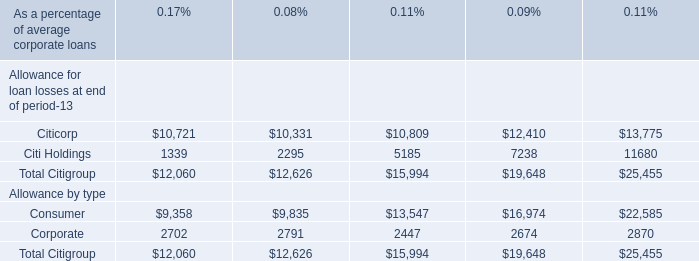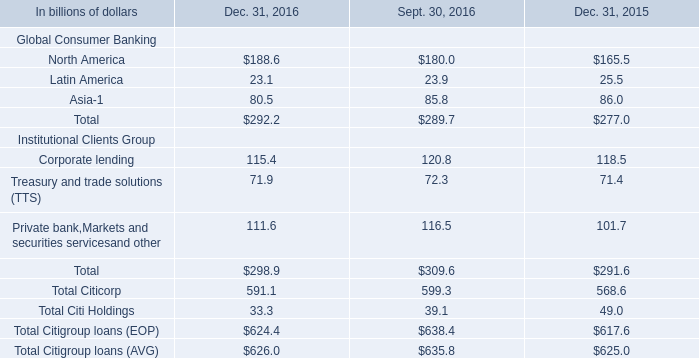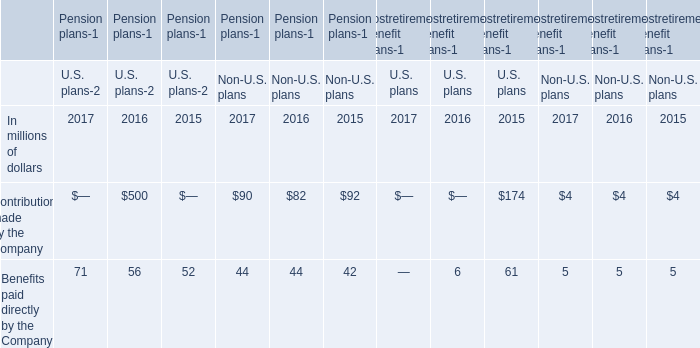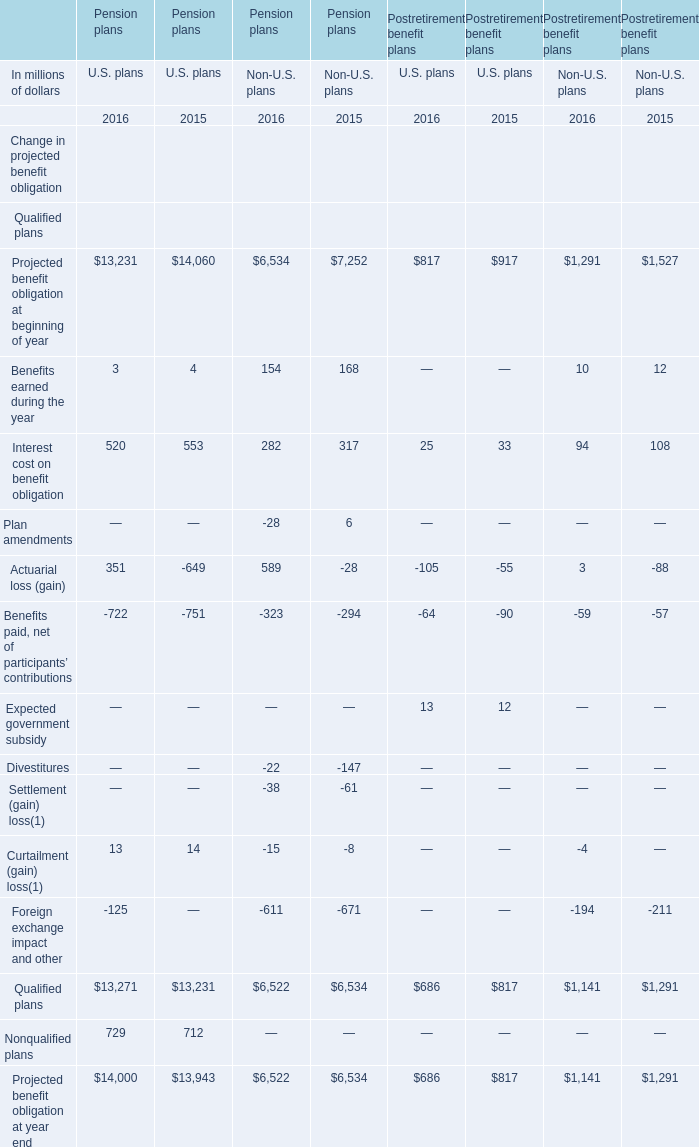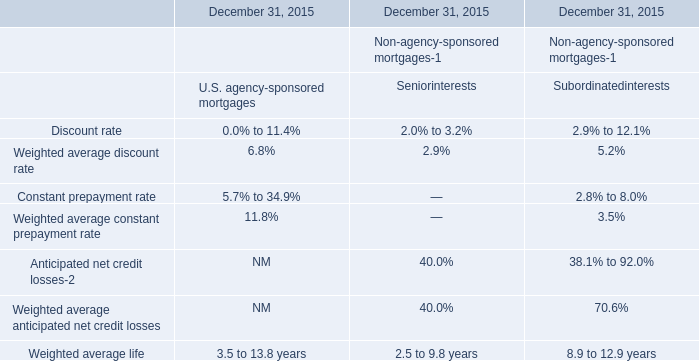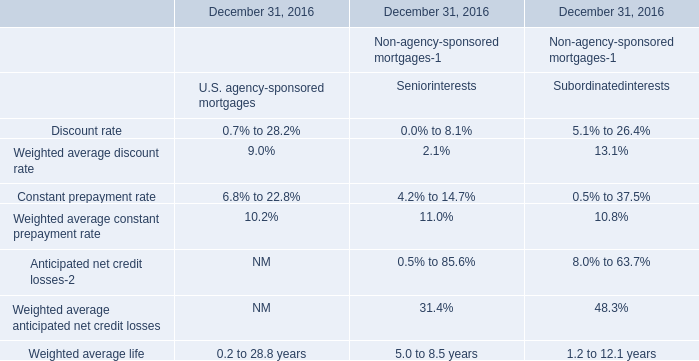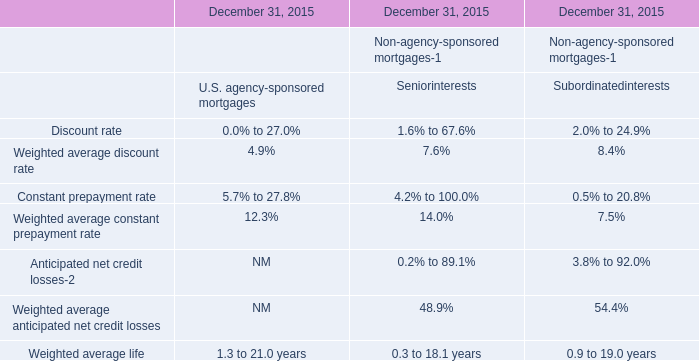In which year is Pension plans U.S. plans Actuarial loss (gain) positive? 
Answer: 2016. 